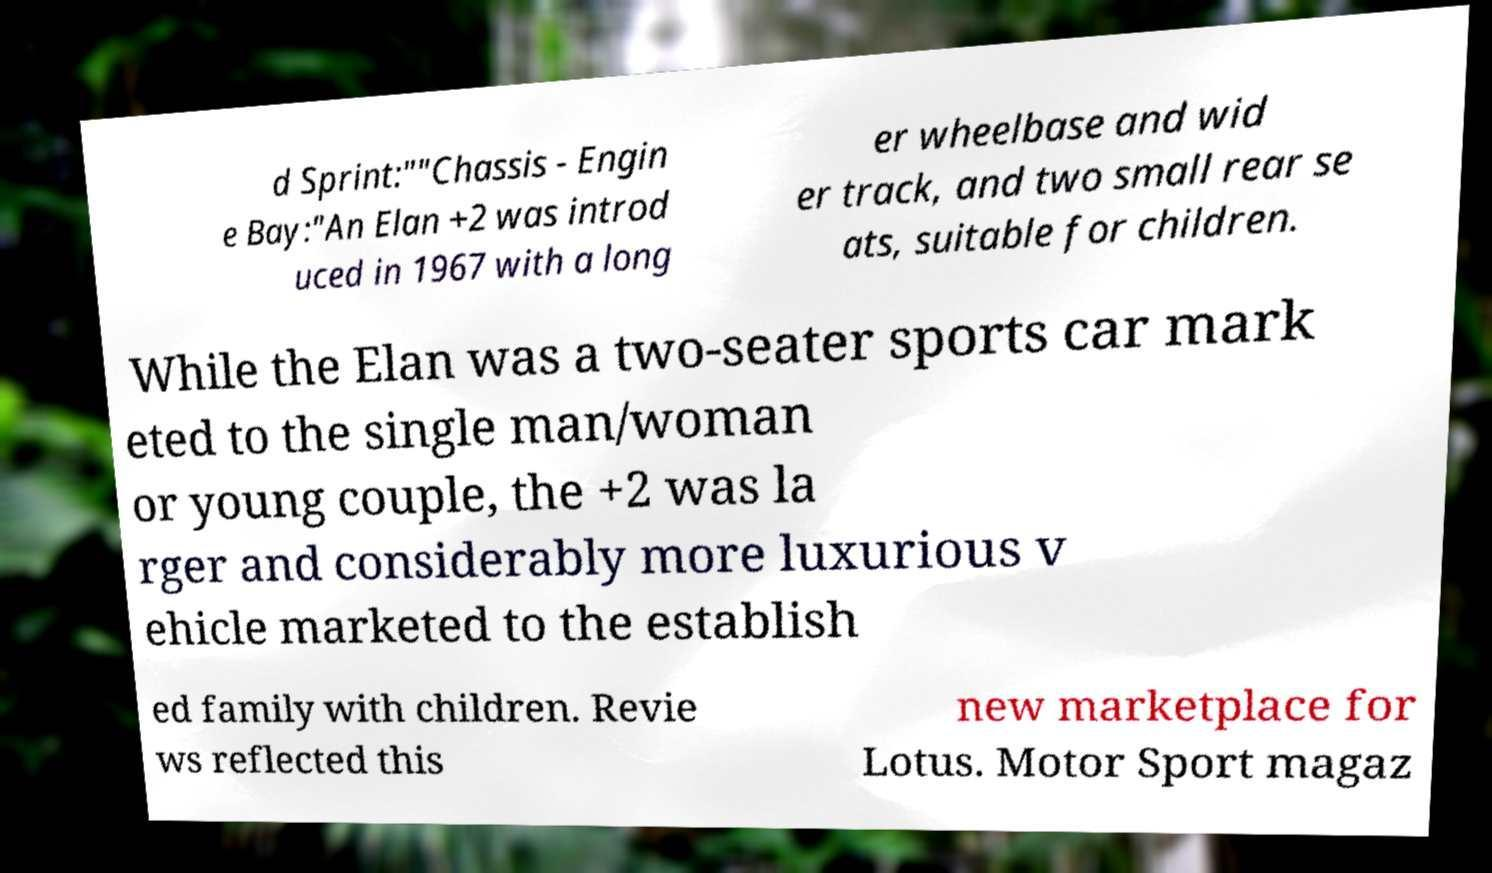Please identify and transcribe the text found in this image. d Sprint:""Chassis - Engin e Bay:"An Elan +2 was introd uced in 1967 with a long er wheelbase and wid er track, and two small rear se ats, suitable for children. While the Elan was a two-seater sports car mark eted to the single man/woman or young couple, the +2 was la rger and considerably more luxurious v ehicle marketed to the establish ed family with children. Revie ws reflected this new marketplace for Lotus. Motor Sport magaz 